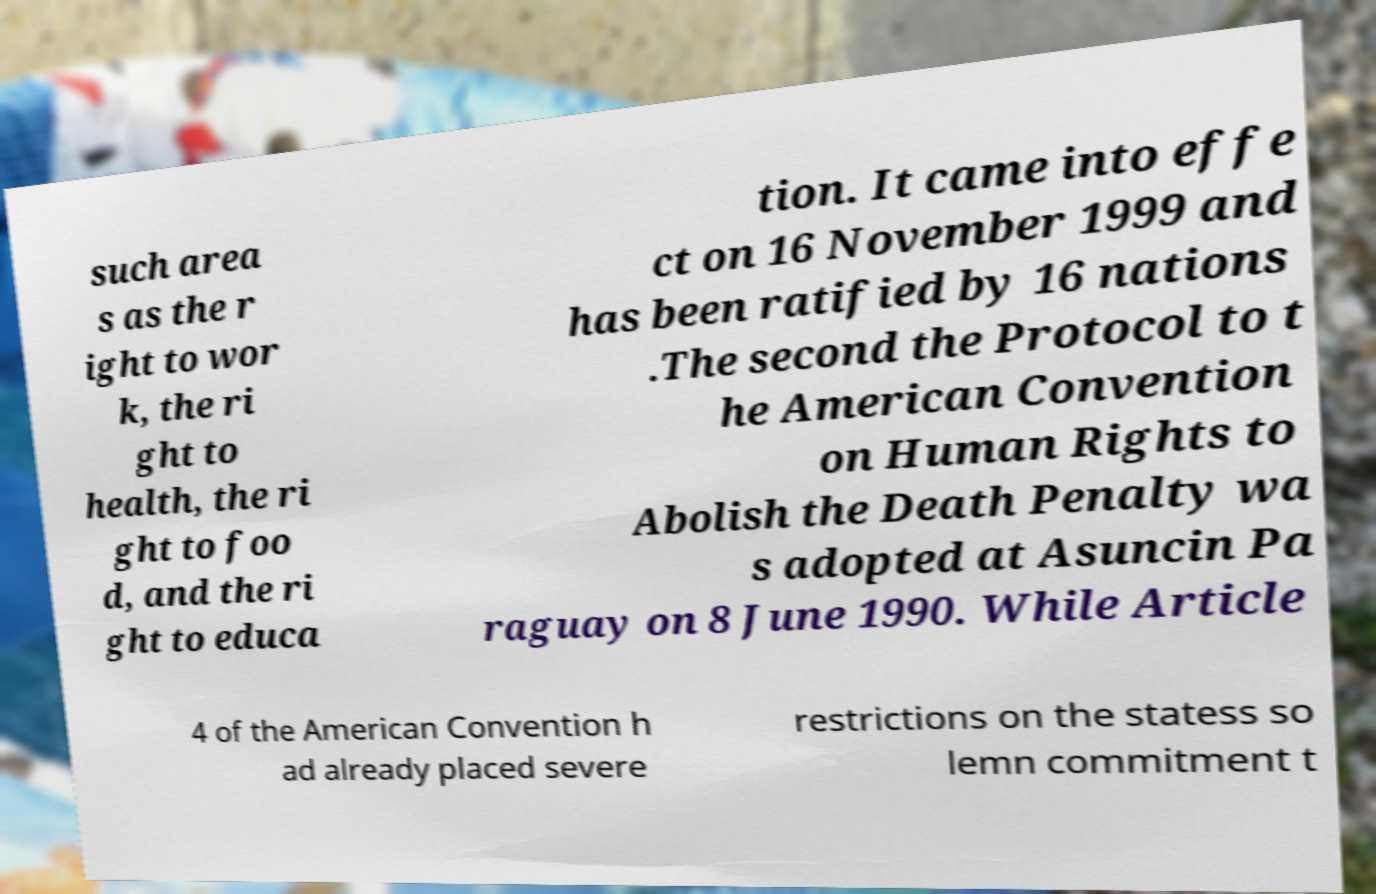Could you extract and type out the text from this image? such area s as the r ight to wor k, the ri ght to health, the ri ght to foo d, and the ri ght to educa tion. It came into effe ct on 16 November 1999 and has been ratified by 16 nations .The second the Protocol to t he American Convention on Human Rights to Abolish the Death Penalty wa s adopted at Asuncin Pa raguay on 8 June 1990. While Article 4 of the American Convention h ad already placed severe restrictions on the statess so lemn commitment t 